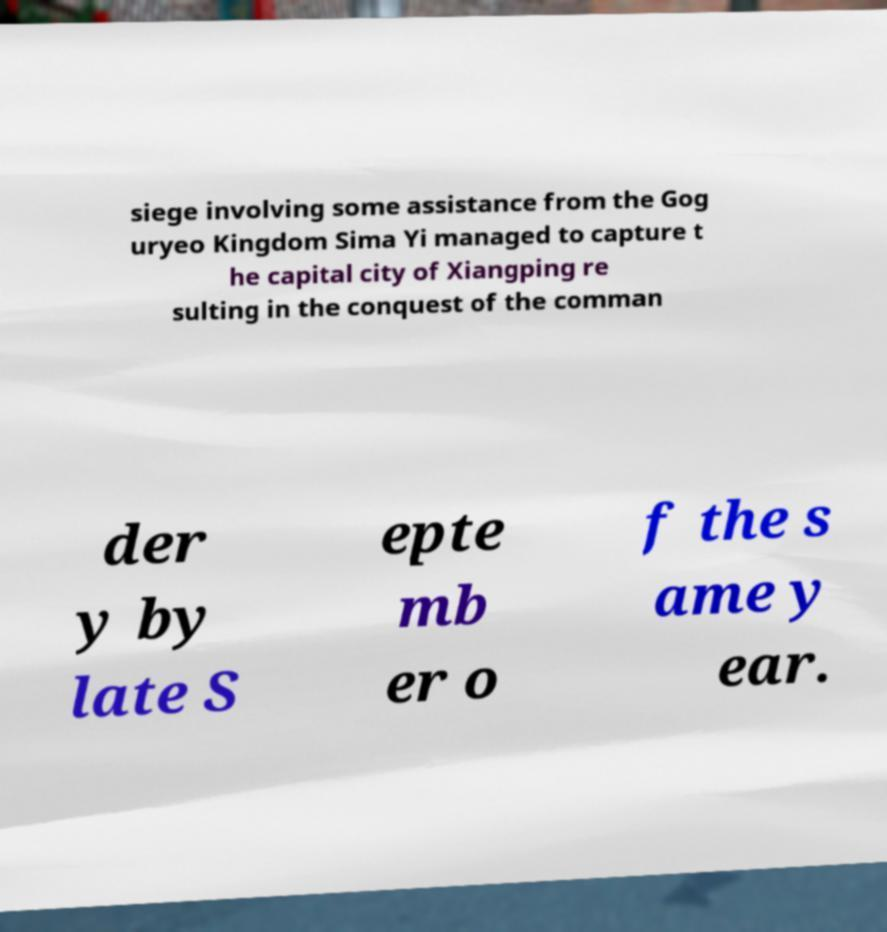Please read and relay the text visible in this image. What does it say? siege involving some assistance from the Gog uryeo Kingdom Sima Yi managed to capture t he capital city of Xiangping re sulting in the conquest of the comman der y by late S epte mb er o f the s ame y ear. 